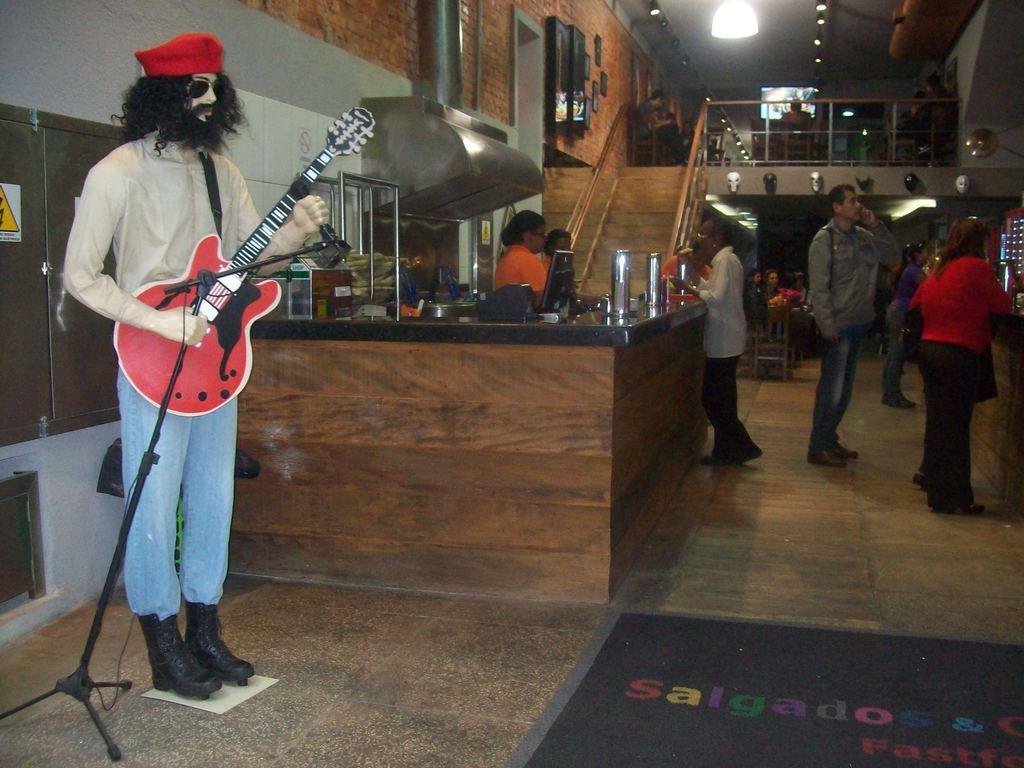Please provide a concise description of this image. There is a statue of a person wearing red cap and goggles and holding a guitar and mic also a mic stand. There are some persons standing in the background. There is a table. On the table there are many items kept like jug. There is a staircase in the background and there is a brick wall. On the wall there are photo frames. There is a light on the ceiling. 